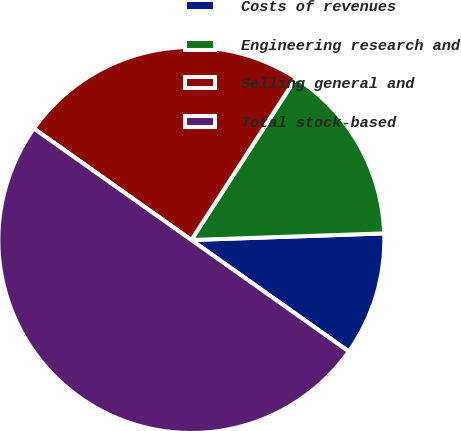Convert chart to OTSL. <chart><loc_0><loc_0><loc_500><loc_500><pie_chart><fcel>Costs of revenues<fcel>Engineering research and<fcel>Selling general and<fcel>Total stock-based<nl><fcel>10.35%<fcel>15.32%<fcel>24.33%<fcel>50.0%<nl></chart> 